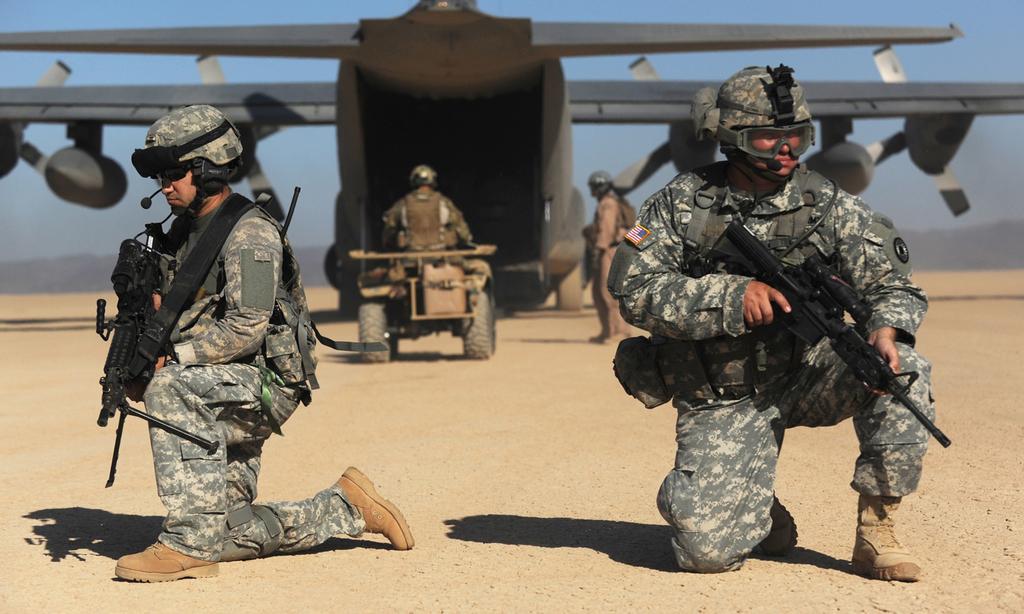Can you describe this image briefly? In this picture I can see 2 men in front who are sitting and I see that they are wearing army uniform and holding guns. In the background I see a person on a vehicle and I see another person near to the vehicle and I see an aeroplane and I see the sky. 